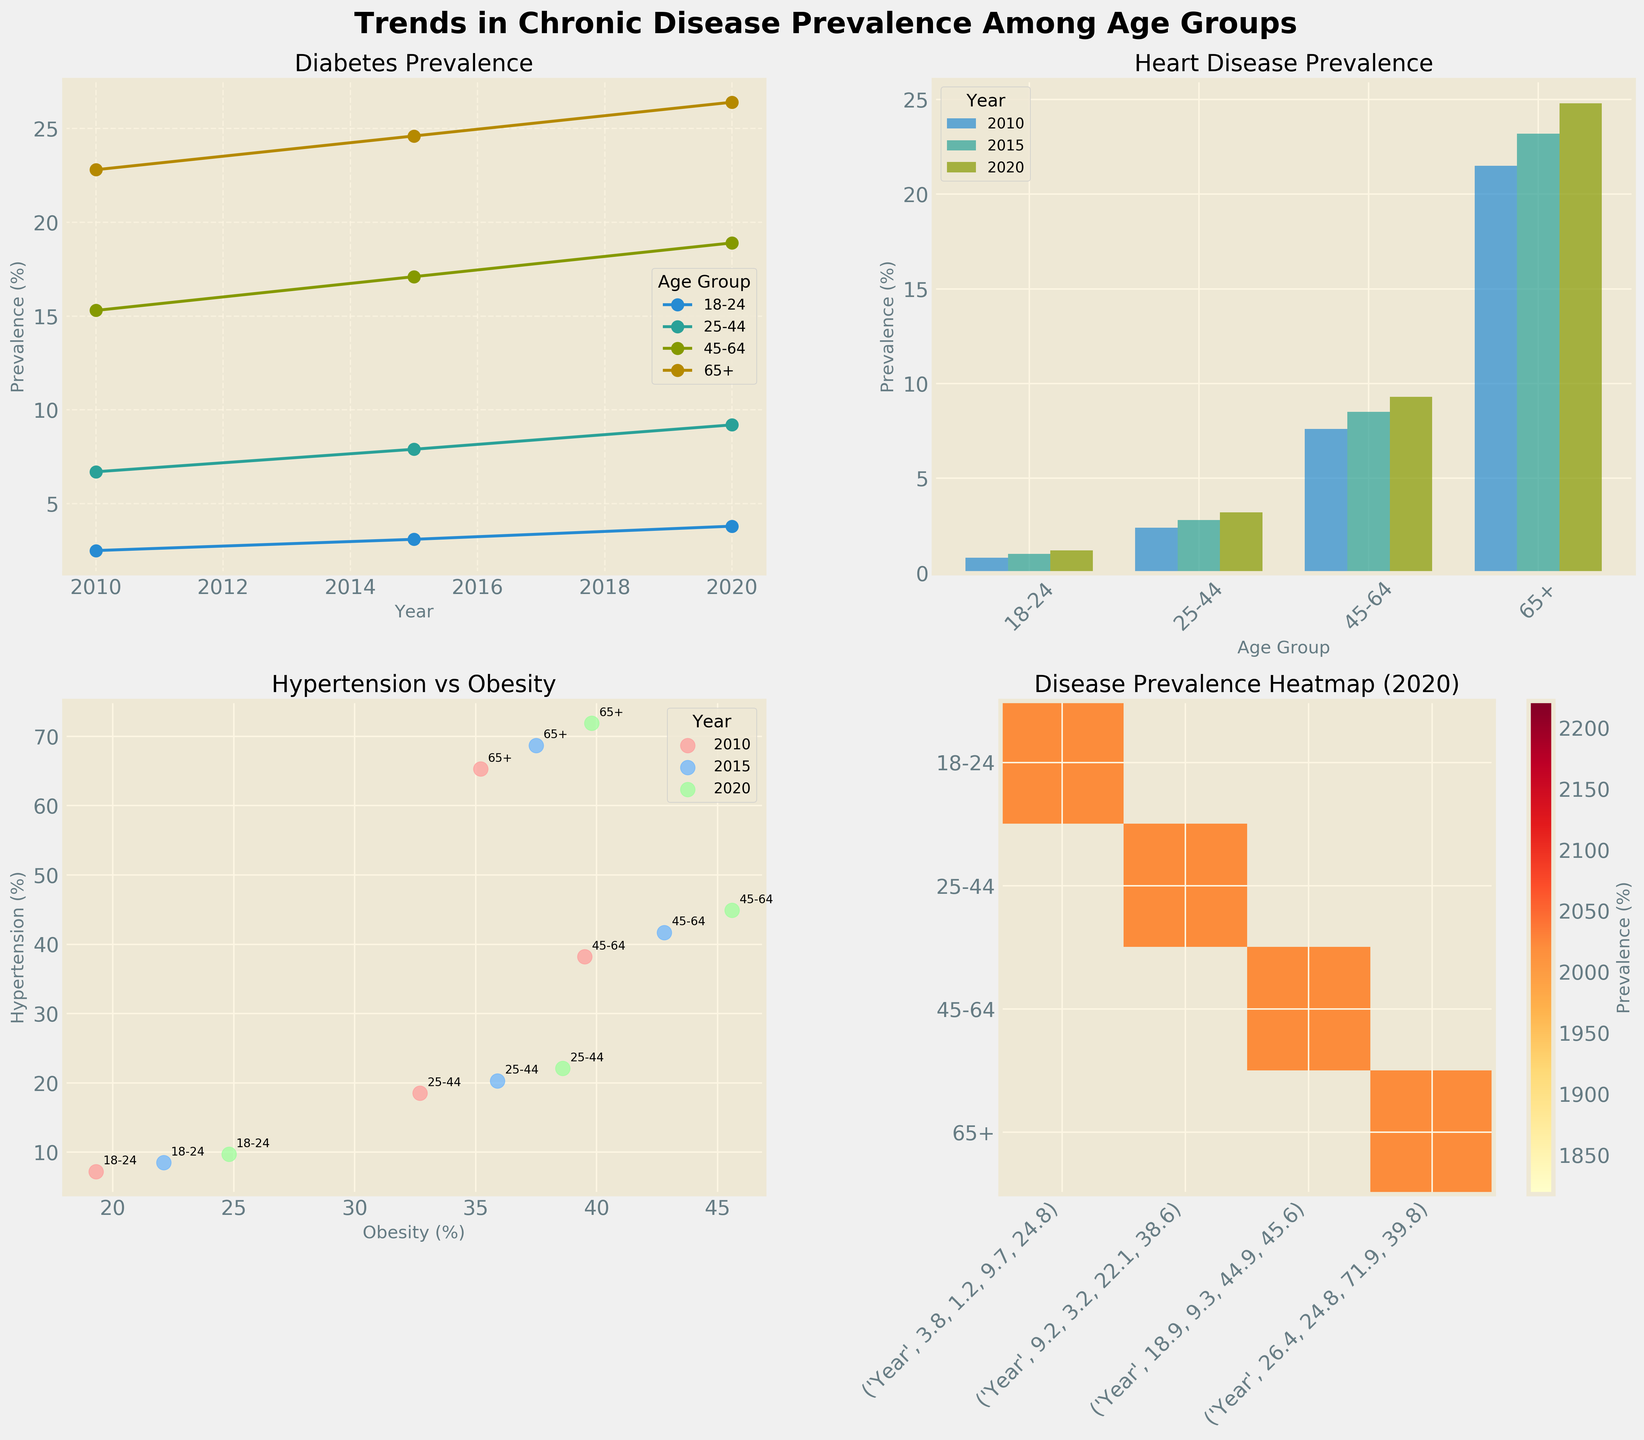How many age groups are depicted in the Diabetes prevalence line plot? Observe the first subplot titled "Diabetes Prevalence." Count the distinct lines, each representing a different age group. There are 4 lines in total, corresponding to the age groups 18-24, 25-44, 45-64, and 65+.
Answer: 4 Which age group had the highest increase in Diabetes prevalence from 2010 to 2020? Look at the Diabetes prevalence line plot and determine the difference between 2020 and 2010 for each age group. The 25-44 age group had an increase from 6.7% to 9.2%, the 45-64 age group from 15.3% to 18.9%, the 18-24 age group from 2.5% to 3.8%, and the 65+ age group from 22.8% to 26.4%. The highest increase is for the 65+ age group (3.6%).
Answer: 65+ What is the overall trend of Heart Disease prevalence across all age groups from 2010 to 2020? Observe the bar plot titled "Heart Disease Prevalence." Note that all trend lines show an upward direction, meaning prevalence increases in each age group. Thus, the overall trend is an increase.
Answer: Increase What is the relationship between Hypertension and Obesity in 2020 based on the scatter plot? Look at the "Hypertension vs Obesity" scatter plot and focus on the data points labeled '2020.' Note that as Obesity percentage increases, Hypertension percentage also increases. This suggests a positive correlation.
Answer: Positive correlation In the heatmap for 2020, which age group shows the highest prevalence of Hypertension? Inspect the heatmap titled "Disease Prevalence Heatmap (2020)." Find the highest value under the Hypertension category. The highest value is 71.9% for the 65+ age group.
Answer: 65+ Between 18-24 and 25-44 age groups, which has a higher prevalence of Obesity in 2020? Look at the years 2020 in the scatter plot or heatmap for Obesity percentages. Compare the values: 18-24 has 24.8%, and 25-44 has 38.6%. Hence, the 25-44 age group has a higher prevalence.
Answer: 25-44 What is the difference in Heart Disease prevalence between 45-64 and 65+ age groups in 2010? Examine the bar plot for the year 2010. Note the Heart Disease prevalence for the 45-64 age group (7.6%) and the 65+ age group (21.5%). Subtract the two values: 21.5% - 7.6% = 13.9%.
Answer: 13.9% What are the axis labels for the Hypertension vs Obesity scatter plot? Locate the scatter plot titled "Hypertension vs Obesity" and read the labels: the x-axis is labeled 'Obesity (%)' and the y-axis is labeled 'Hypertension (%).'
Answer: Obesity (%) and Hypertension (%) Which year shows the highest overall prevalence for Diabetes in the line plot? Observe the lines in the Diabetes prevalence line plot. Focus on the end of each line (the year 2020). Compare the final values for each age group: 3.8% (18-24), 9.2% (25-44), 18.9% (45-64), and 26.4% (65+). All age groups show the highest values in 2020.
Answer: 2020 